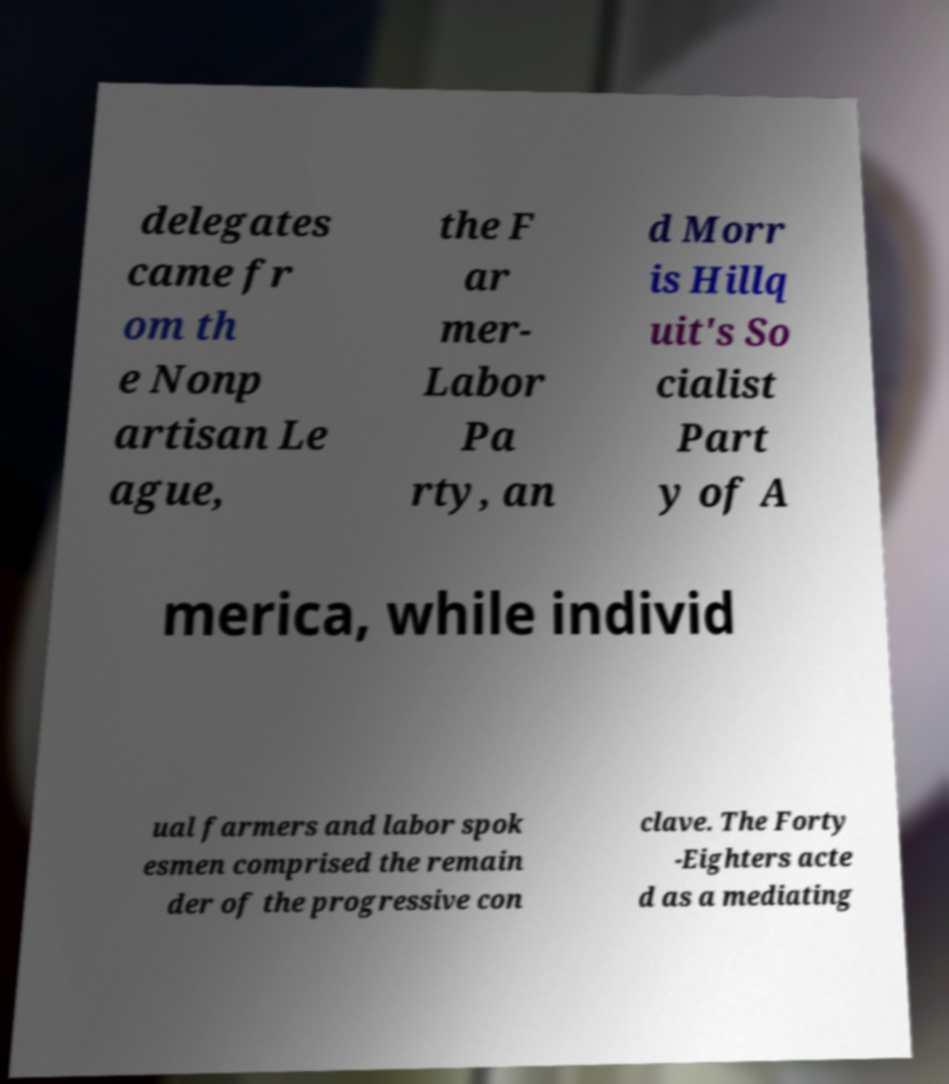What messages or text are displayed in this image? I need them in a readable, typed format. delegates came fr om th e Nonp artisan Le ague, the F ar mer- Labor Pa rty, an d Morr is Hillq uit's So cialist Part y of A merica, while individ ual farmers and labor spok esmen comprised the remain der of the progressive con clave. The Forty -Eighters acte d as a mediating 